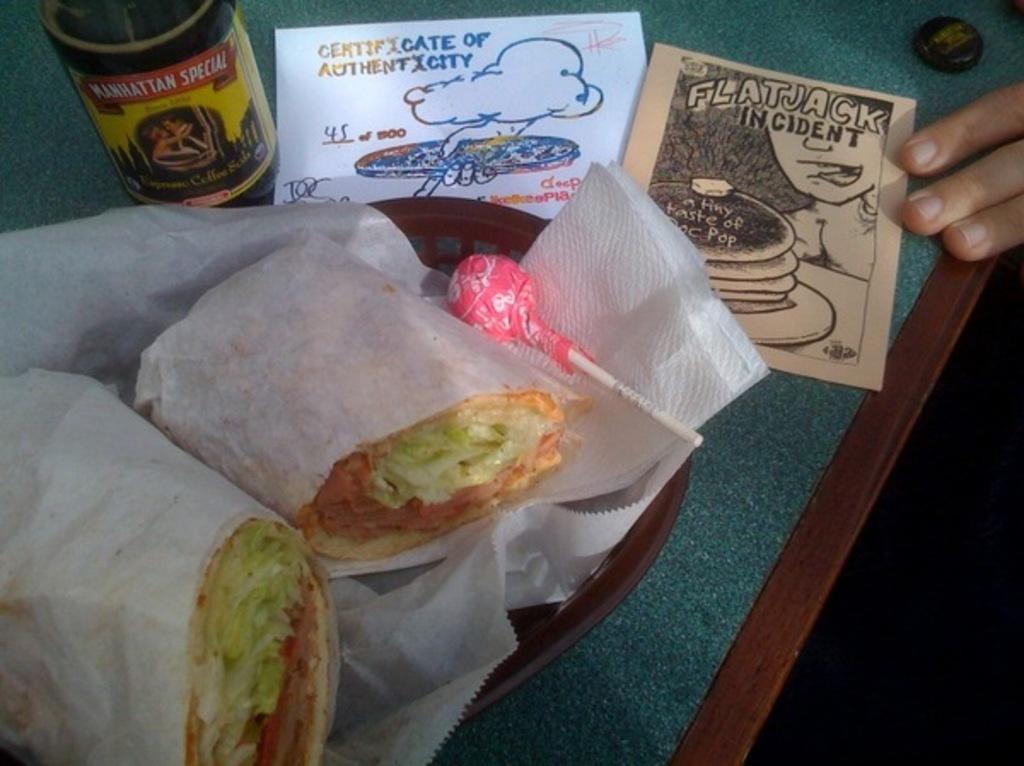Could you give a brief overview of what you see in this image? In this image we can see a table on which there is a basket with food items in it. There are papers. There is a bottle. To the right side of the image there are persons fingers. 